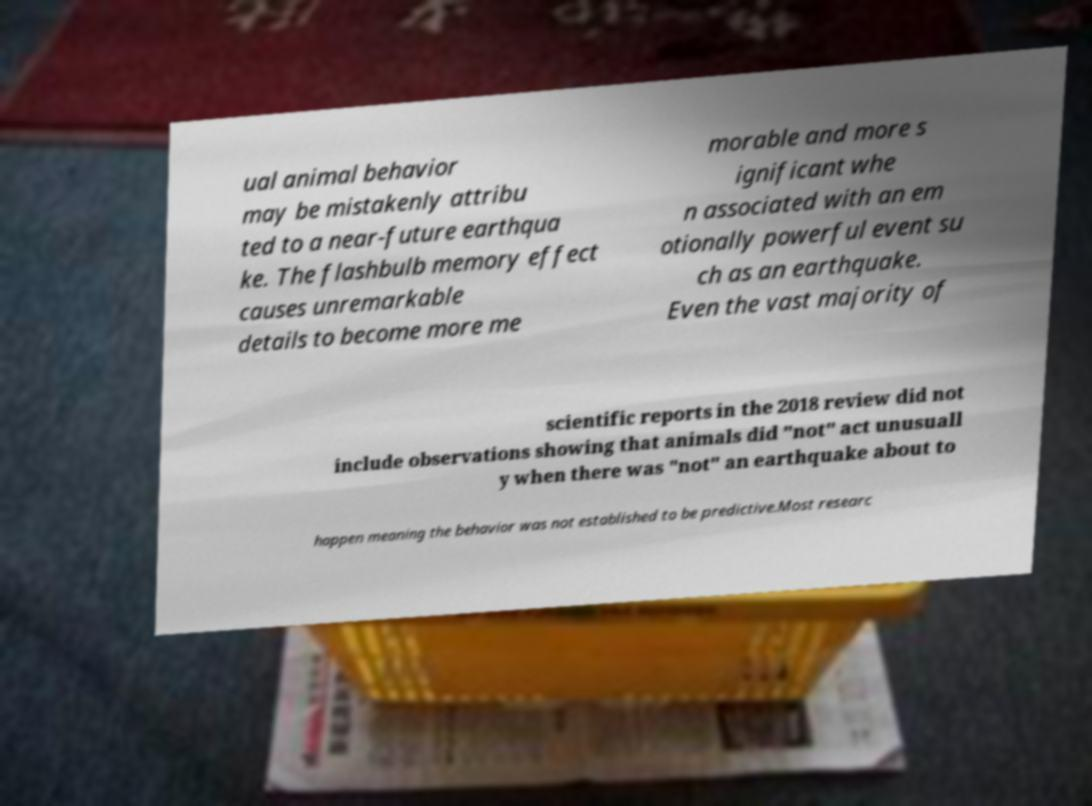There's text embedded in this image that I need extracted. Can you transcribe it verbatim? ual animal behavior may be mistakenly attribu ted to a near-future earthqua ke. The flashbulb memory effect causes unremarkable details to become more me morable and more s ignificant whe n associated with an em otionally powerful event su ch as an earthquake. Even the vast majority of scientific reports in the 2018 review did not include observations showing that animals did "not" act unusuall y when there was "not" an earthquake about to happen meaning the behavior was not established to be predictive.Most researc 